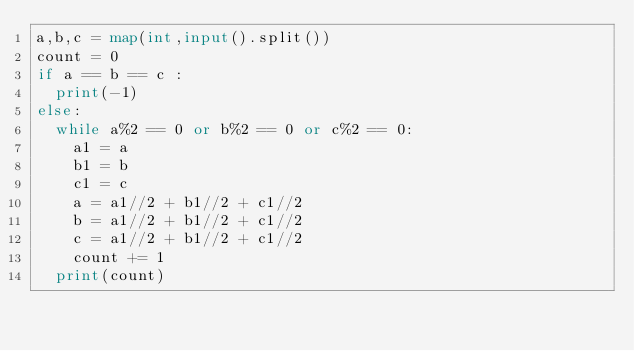<code> <loc_0><loc_0><loc_500><loc_500><_Python_>a,b,c = map(int,input().split())
count = 0
if a == b == c :
  print(-1)
else:
  while a%2 == 0 or b%2 == 0 or c%2 == 0:
    a1 = a
    b1 = b
    c1 = c
    a = a1//2 + b1//2 + c1//2
    b = a1//2 + b1//2 + c1//2
    c = a1//2 + b1//2 + c1//2
    count += 1
  print(count)
</code> 